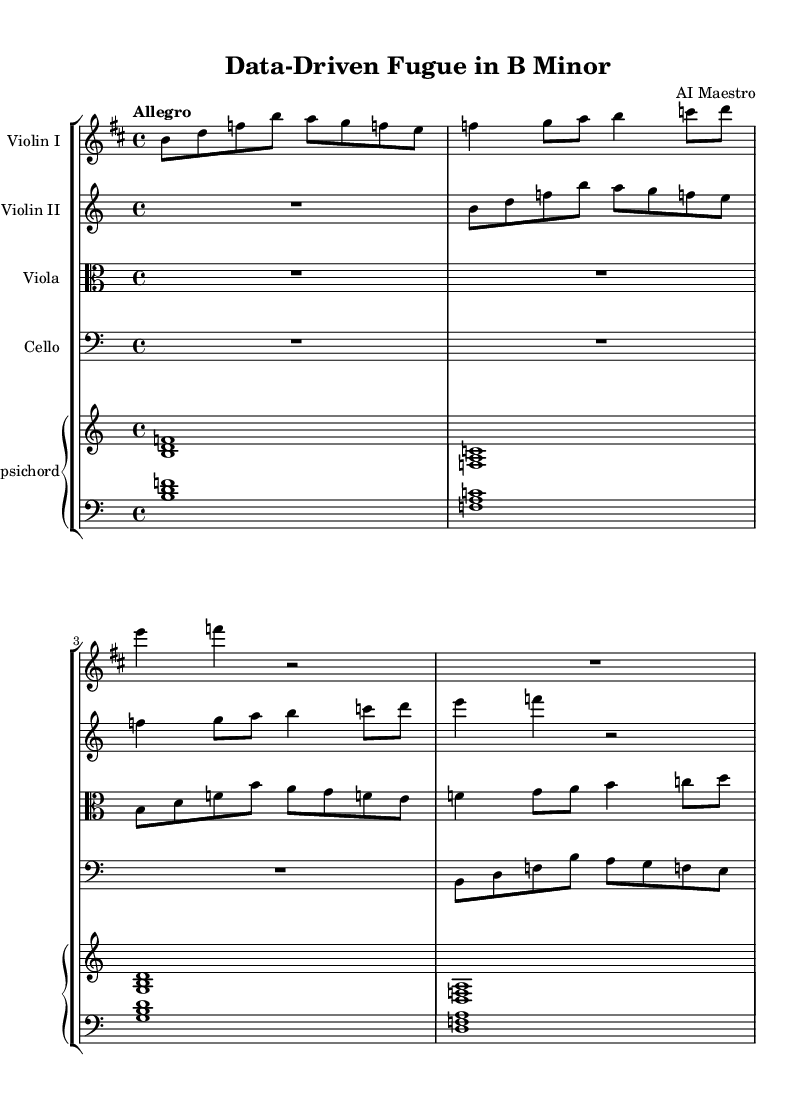What is the key signature of this music? The key signature is indicated at the beginning of the staff, which shows two sharps. This corresponds to the key of B minor.
Answer: B minor What is the time signature of this music? The time signature is shown at the start of the score, which displays a "4" over a "4". This indicates that there are four beats in each measure and a quarter note receives one beat.
Answer: 4/4 What is the tempo marking for the piece? The tempo marking is found below the title and specifies "Allegro," which denotes a fast tempo.
Answer: Allegro How many measures are present in the violin I part? By counting the measures indicated by vertical lines in the violin I staff, we find that there are four measures.
Answer: 4 Which instruments are included in this score? The score lists five instruments: Violin I, Violin II, Viola, Cello, and Harpsichord. These are derived from the headers above each staff.
Answer: Violin I, Violin II, Viola, Cello, Harpsichord What is the last note played by the cello? The last note played by the cello, as seen in the notation, is a G note, which is indicated as a quarter note in the fourth measure.
Answer: G Identify a notable structural feature of the piece related to its Baroque style. The piece exhibits a fugue structure, as suggested by the title "Data-Driven Fugue in B Minor," which reflects the structured complexity characteristic of Baroque orchestral music.
Answer: Fugue 